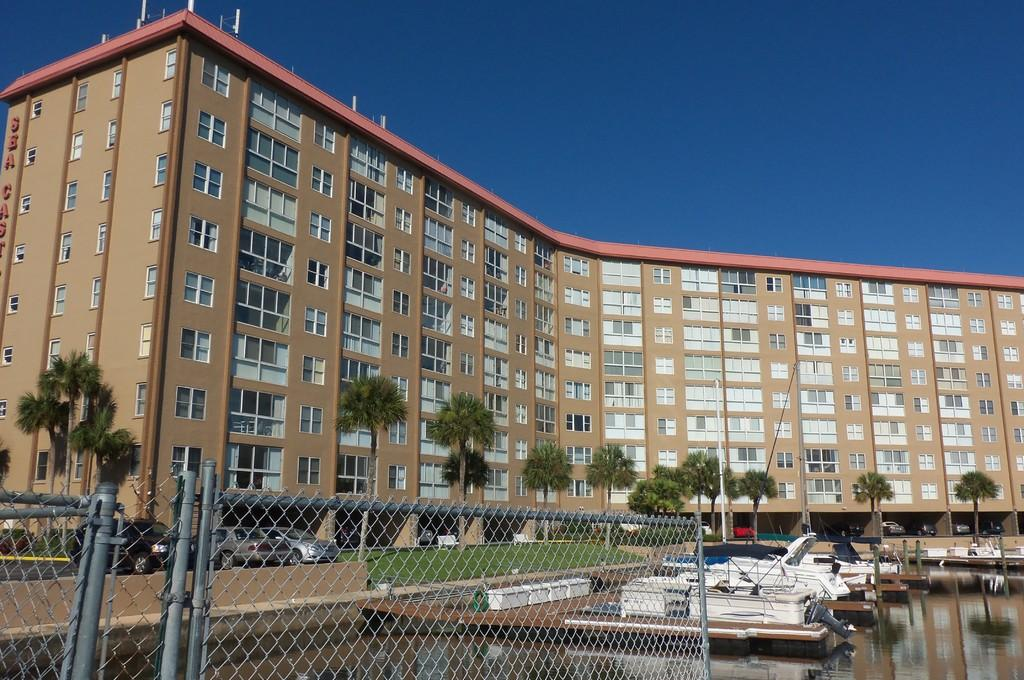What type of structure is present in the image? There is a building in the image. What feature can be observed on the building? The building has windows. What other objects can be seen in the image? There are trees, vehicles, net fencing, and boats on the water surface visible in the image. What is the color of the sky in the image? The sky is blue in color. Can you see any giants walking around in the image? No, there are no giants present in the image. What type of berry is growing on the trees in the image? There are no berries mentioned or visible in the image; the trees are not specified as fruit-bearing trees. 